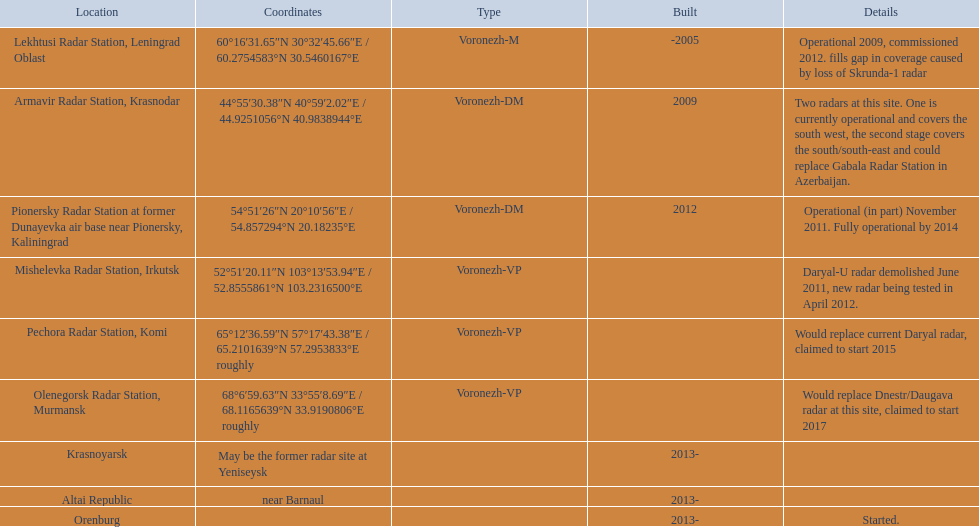Prior to 2010, what was the number of voronezh radars constructed? 2. Parse the full table. {'header': ['Location', 'Coordinates', 'Type', 'Built', 'Details'], 'rows': [['Lekhtusi Radar Station, Leningrad Oblast', '60°16′31.65″N 30°32′45.66″E\ufeff / \ufeff60.2754583°N 30.5460167°E', 'Voronezh-M', '-2005', 'Operational 2009, commissioned 2012. fills gap in coverage caused by loss of Skrunda-1 radar'], ['Armavir Radar Station, Krasnodar', '44°55′30.38″N 40°59′2.02″E\ufeff / \ufeff44.9251056°N 40.9838944°E', 'Voronezh-DM', '2009', 'Two radars at this site. One is currently operational and covers the south west, the second stage covers the south/south-east and could replace Gabala Radar Station in Azerbaijan.'], ['Pionersky Radar Station at former Dunayevka air base near Pionersky, Kaliningrad', '54°51′26″N 20°10′56″E\ufeff / \ufeff54.857294°N 20.18235°E', 'Voronezh-DM', '2012', 'Operational (in part) November 2011. Fully operational by 2014'], ['Mishelevka Radar Station, Irkutsk', '52°51′20.11″N 103°13′53.94″E\ufeff / \ufeff52.8555861°N 103.2316500°E', 'Voronezh-VP', '', 'Daryal-U radar demolished June 2011, new radar being tested in April 2012.'], ['Pechora Radar Station, Komi', '65°12′36.59″N 57°17′43.38″E\ufeff / \ufeff65.2101639°N 57.2953833°E roughly', 'Voronezh-VP', '', 'Would replace current Daryal radar, claimed to start 2015'], ['Olenegorsk Radar Station, Murmansk', '68°6′59.63″N 33°55′8.69″E\ufeff / \ufeff68.1165639°N 33.9190806°E roughly', 'Voronezh-VP', '', 'Would replace Dnestr/Daugava radar at this site, claimed to start 2017'], ['Krasnoyarsk', 'May be the former radar site at Yeniseysk', '', '2013-', ''], ['Altai Republic', 'near Barnaul', '', '2013-', ''], ['Orenburg', '', '', '2013-', 'Started.']]} 